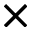Convert formula to latex. <formula><loc_0><loc_0><loc_500><loc_500>\times</formula> 